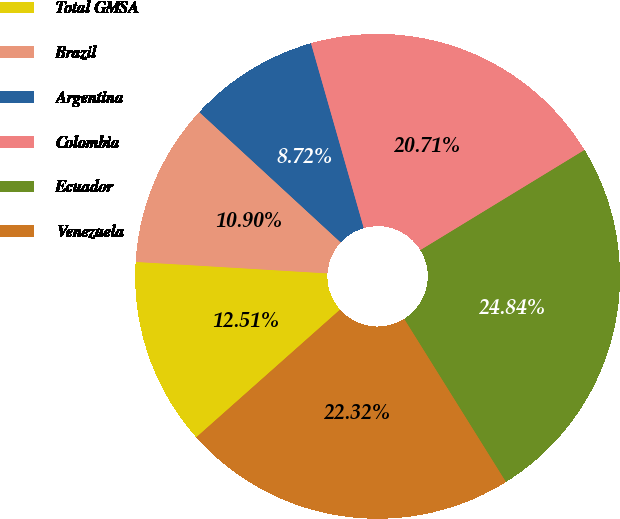Convert chart to OTSL. <chart><loc_0><loc_0><loc_500><loc_500><pie_chart><fcel>Total GMSA<fcel>Brazil<fcel>Argentina<fcel>Colombia<fcel>Ecuador<fcel>Venezuela<nl><fcel>12.51%<fcel>10.9%<fcel>8.72%<fcel>20.71%<fcel>24.84%<fcel>22.32%<nl></chart> 